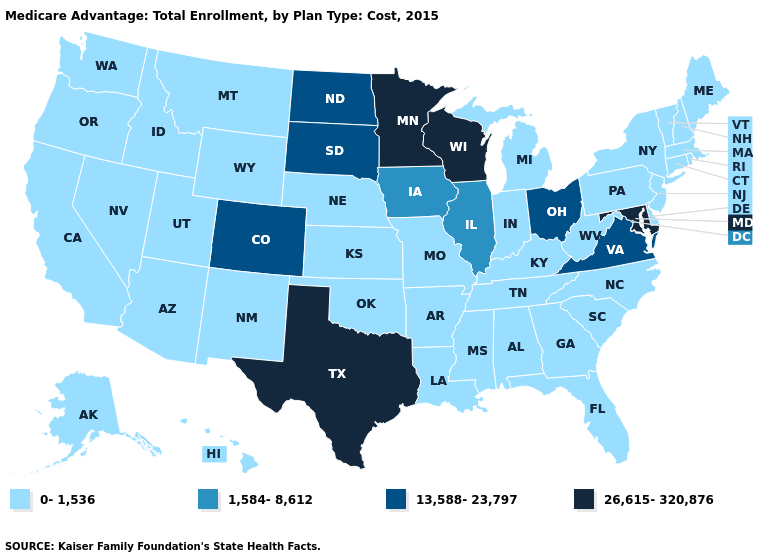What is the value of Florida?
Be succinct. 0-1,536. Among the states that border Utah , does Colorado have the highest value?
Give a very brief answer. Yes. Does Minnesota have the highest value in the USA?
Be succinct. Yes. What is the value of Colorado?
Be succinct. 13,588-23,797. Name the states that have a value in the range 13,588-23,797?
Give a very brief answer. Colorado, North Dakota, Ohio, South Dakota, Virginia. What is the value of Missouri?
Short answer required. 0-1,536. Does Arkansas have the highest value in the South?
Answer briefly. No. Does Minnesota have the highest value in the USA?
Answer briefly. Yes. Name the states that have a value in the range 26,615-320,876?
Be succinct. Maryland, Minnesota, Texas, Wisconsin. What is the highest value in the USA?
Concise answer only. 26,615-320,876. What is the lowest value in states that border New Mexico?
Write a very short answer. 0-1,536. Which states have the lowest value in the MidWest?
Concise answer only. Indiana, Kansas, Michigan, Missouri, Nebraska. Which states have the lowest value in the West?
Quick response, please. Alaska, Arizona, California, Hawaii, Idaho, Montana, New Mexico, Nevada, Oregon, Utah, Washington, Wyoming. Name the states that have a value in the range 1,584-8,612?
Short answer required. Iowa, Illinois. 